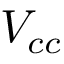Convert formula to latex. <formula><loc_0><loc_0><loc_500><loc_500>V _ { c c }</formula> 